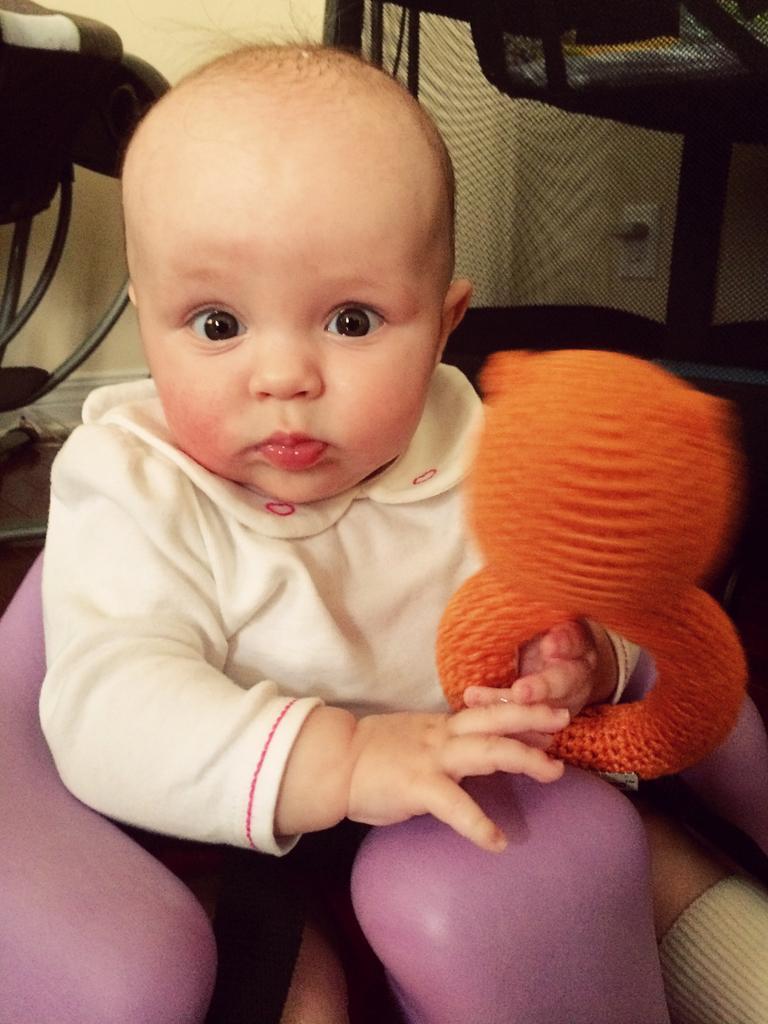How would you summarize this image in a sentence or two? In this image we can see a baby sitting and holding something in the hand. In the background there are some objects. 